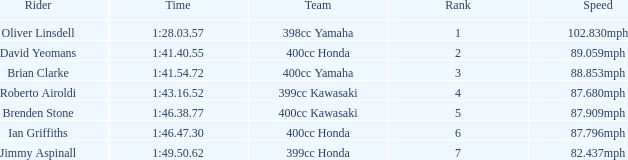What is the time of the rider with a 398cc yamaha? 1:28.03.57. Could you parse the entire table? {'header': ['Rider', 'Time', 'Team', 'Rank', 'Speed'], 'rows': [['Oliver Linsdell', '1:28.03.57', '398cc Yamaha', '1', '102.830mph'], ['David Yeomans', '1:41.40.55', '400cc Honda', '2', '89.059mph'], ['Brian Clarke', '1:41.54.72', '400cc Yamaha', '3', '88.853mph'], ['Roberto Airoldi', '1:43.16.52', '399cc Kawasaki', '4', '87.680mph'], ['Brenden Stone', '1:46.38.77', '400cc Kawasaki', '5', '87.909mph'], ['Ian Griffiths', '1:46.47.30', '400cc Honda', '6', '87.796mph'], ['Jimmy Aspinall', '1:49.50.62', '399cc Honda', '7', '82.437mph']]} 